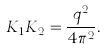Convert formula to latex. <formula><loc_0><loc_0><loc_500><loc_500>K _ { 1 } K _ { 2 } = \frac { q ^ { 2 } } { 4 \pi ^ { 2 } } .</formula> 